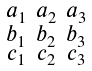<formula> <loc_0><loc_0><loc_500><loc_500>\begin{smallmatrix} a _ { 1 } & a _ { 2 } & a _ { 3 } \\ b _ { 1 } & b _ { 2 } & b _ { 3 } \\ c _ { 1 } & c _ { 2 } & c _ { 3 } \\ \end{smallmatrix}</formula> 